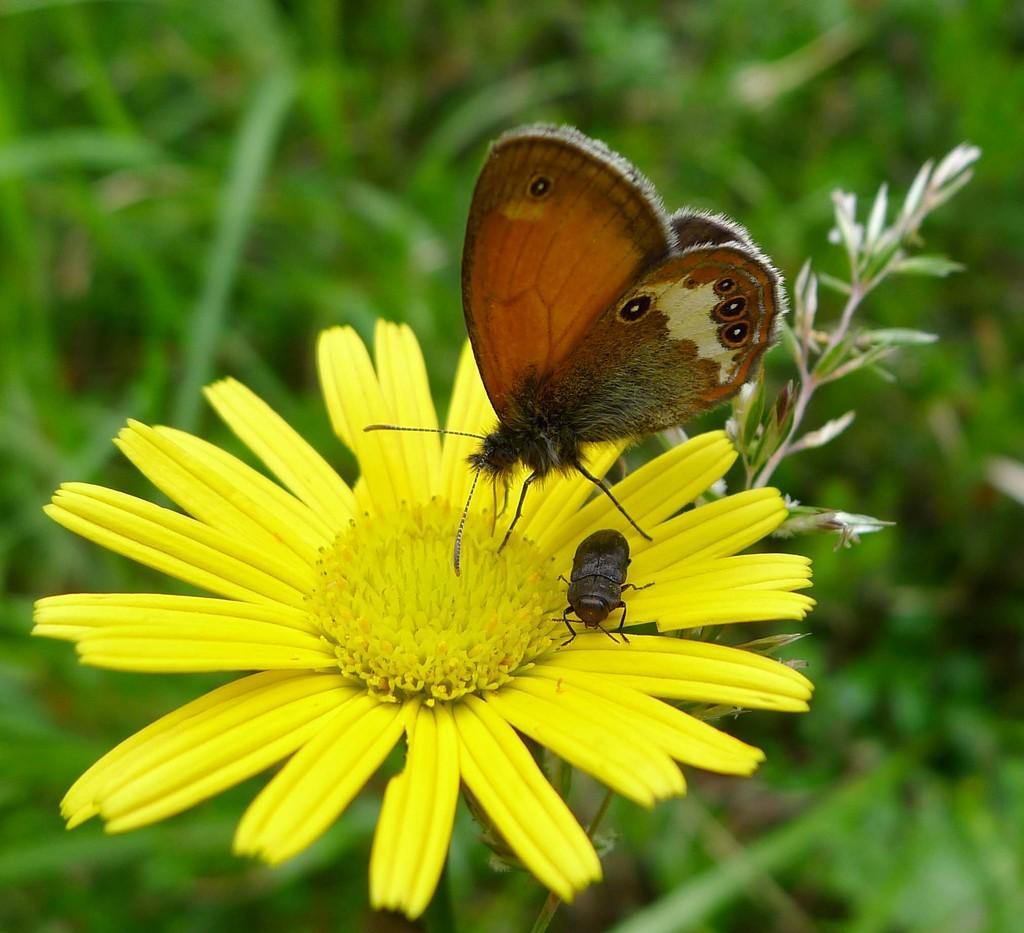What is the butterfly doing in the image? The butterfly is on a yellow sunflower in the image. What other insect can be seen on the yellow sunflower? There is an insect on the yellow sunflower in the image. What color is the sunflower? The sunflower is yellow in color. What type of vegetation is visible in the background? There are green plants in the background. What type of friction can be observed between the butterfly and the sunflower in the image? There is no friction observable between the butterfly and the sunflower in the image, as they are not interacting in a way that would cause friction. 